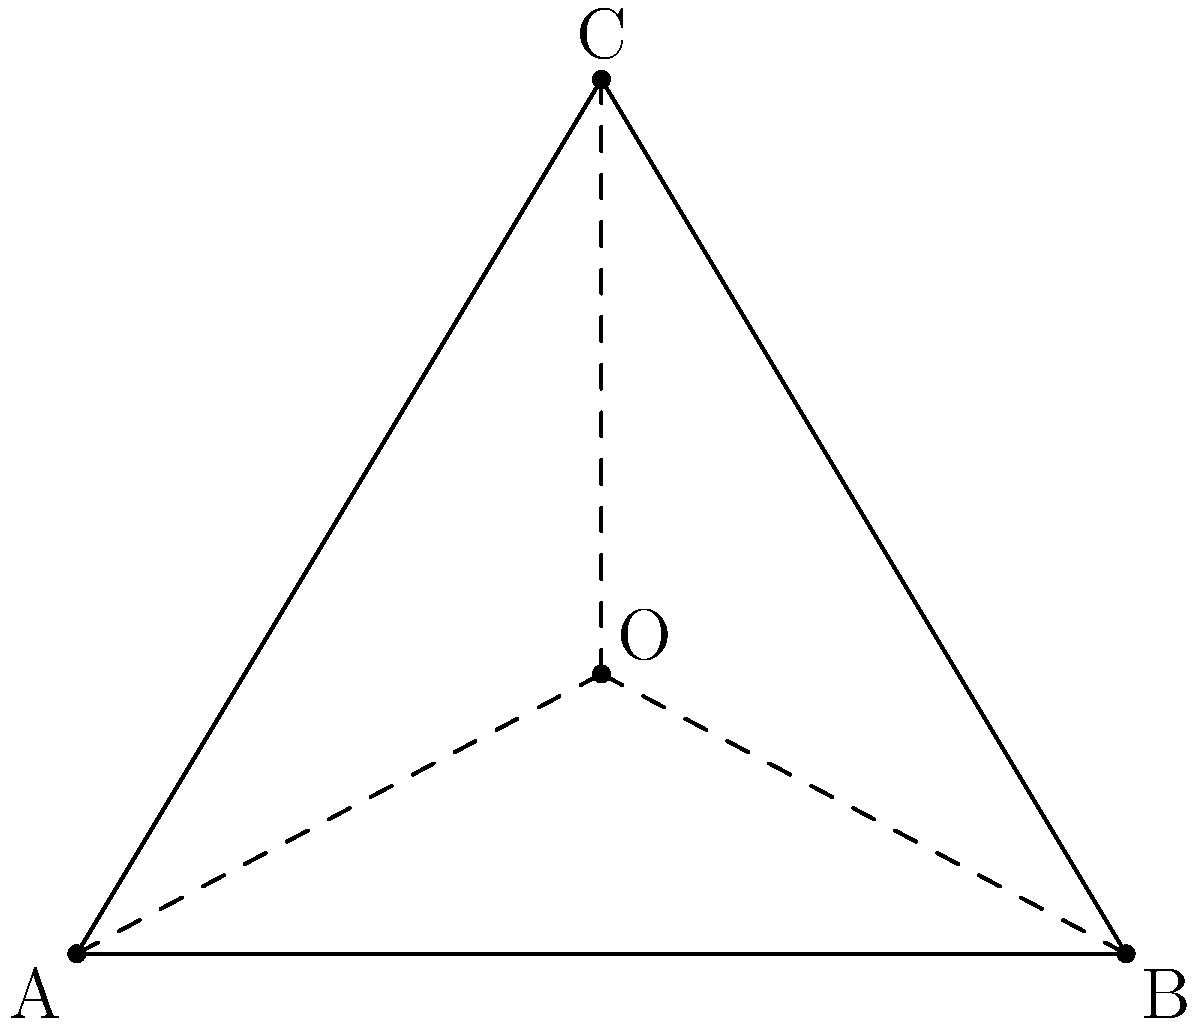Three police stations are located at coordinates A(0,0), B(6,0), and C(3,5) in a city grid system. A crime scene is reported to be equidistant from all three stations. Find the coordinates of the crime scene. To find the coordinates of the crime scene, we need to determine the circumcenter of the triangle formed by the three police stations. The circumcenter is equidistant from all three vertices of the triangle.

Step 1: Find the equations of the perpendicular bisectors of two sides of the triangle.

1a. Midpoint of AB: $(\frac{0+6}{2}, \frac{0+0}{2}) = (3,0)$
    Slope of AB: $m_{AB} = 0$
    Perpendicular slope: $m_1 = \text{undefined}$
    Equation of perpendicular bisector of AB: $x = 3$

1b. Midpoint of BC: $(\frac{6+3}{2}, \frac{0+5}{2}) = (4.5, 2.5)$
    Slope of BC: $m_{BC} = \frac{5-0}{3-6} = -\frac{5}{3}$
    Perpendicular slope: $m_2 = \frac{3}{5}$
    Equation of perpendicular bisector of BC: $y - 2.5 = \frac{3}{5}(x - 4.5)$

Step 2: Find the intersection of the two perpendicular bisectors.

$x = 3$
$y - 2.5 = \frac{3}{5}(3 - 4.5) = -\frac{9}{10}$
$y = 2.5 - \frac{9}{10} = \frac{25}{10} - \frac{9}{10} = \frac{16}{10} = 1.6$

Therefore, the coordinates of the circumcenter (crime scene) are (3, 1.6).

Step 3: Verify that this point is equidistant from all three stations.

Distance from (3, 1.6) to A(0,0): $\sqrt{(3-0)^2 + (1.6-0)^2} \approx 3.4$
Distance from (3, 1.6) to B(6,0): $\sqrt{(3-6)^2 + (1.6-0)^2} \approx 3.4$
Distance from (3, 1.6) to C(3,5): $\sqrt{(3-3)^2 + (1.6-5)^2} \approx 3.4$

All distances are equal, confirming that (3, 1.6) is the correct location.
Answer: (3, 1.6) 